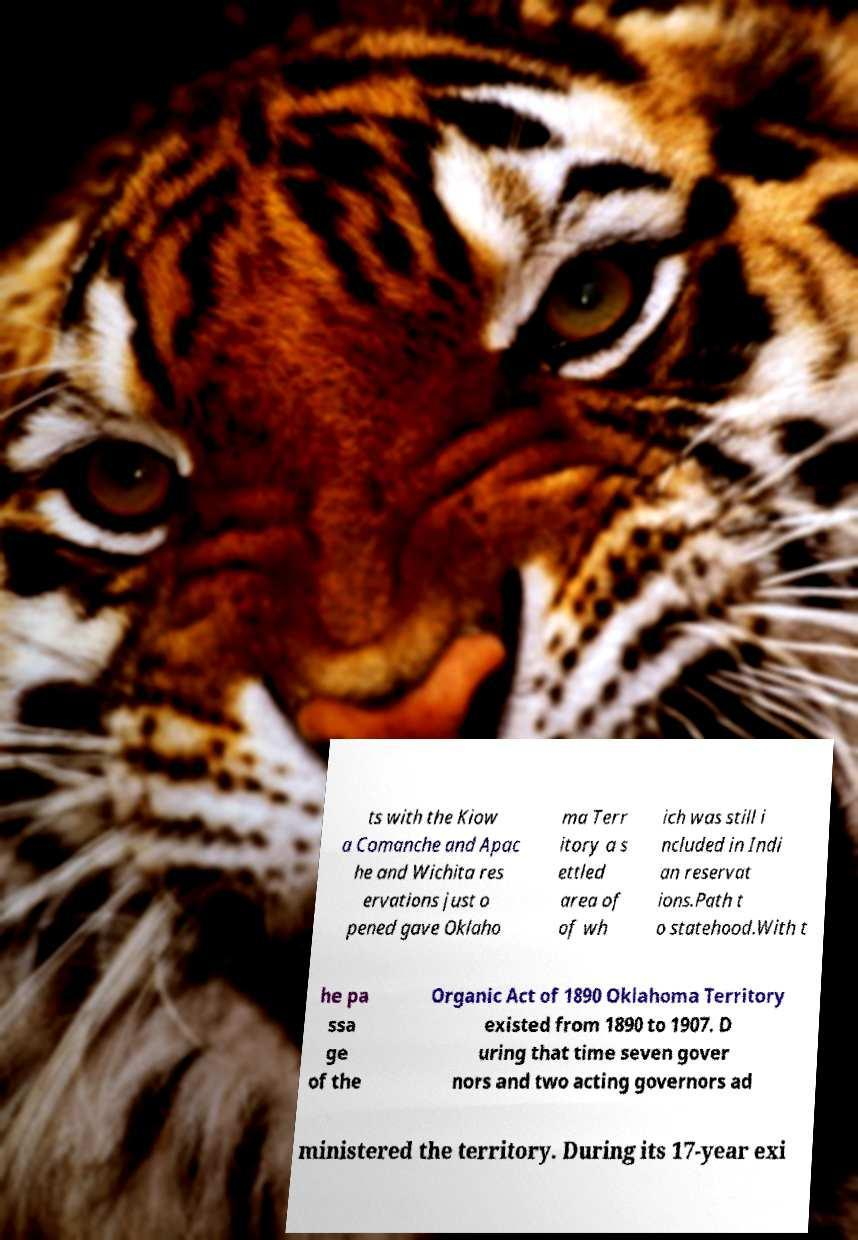Please identify and transcribe the text found in this image. ts with the Kiow a Comanche and Apac he and Wichita res ervations just o pened gave Oklaho ma Terr itory a s ettled area of of wh ich was still i ncluded in Indi an reservat ions.Path t o statehood.With t he pa ssa ge of the Organic Act of 1890 Oklahoma Territory existed from 1890 to 1907. D uring that time seven gover nors and two acting governors ad ministered the territory. During its 17-year exi 